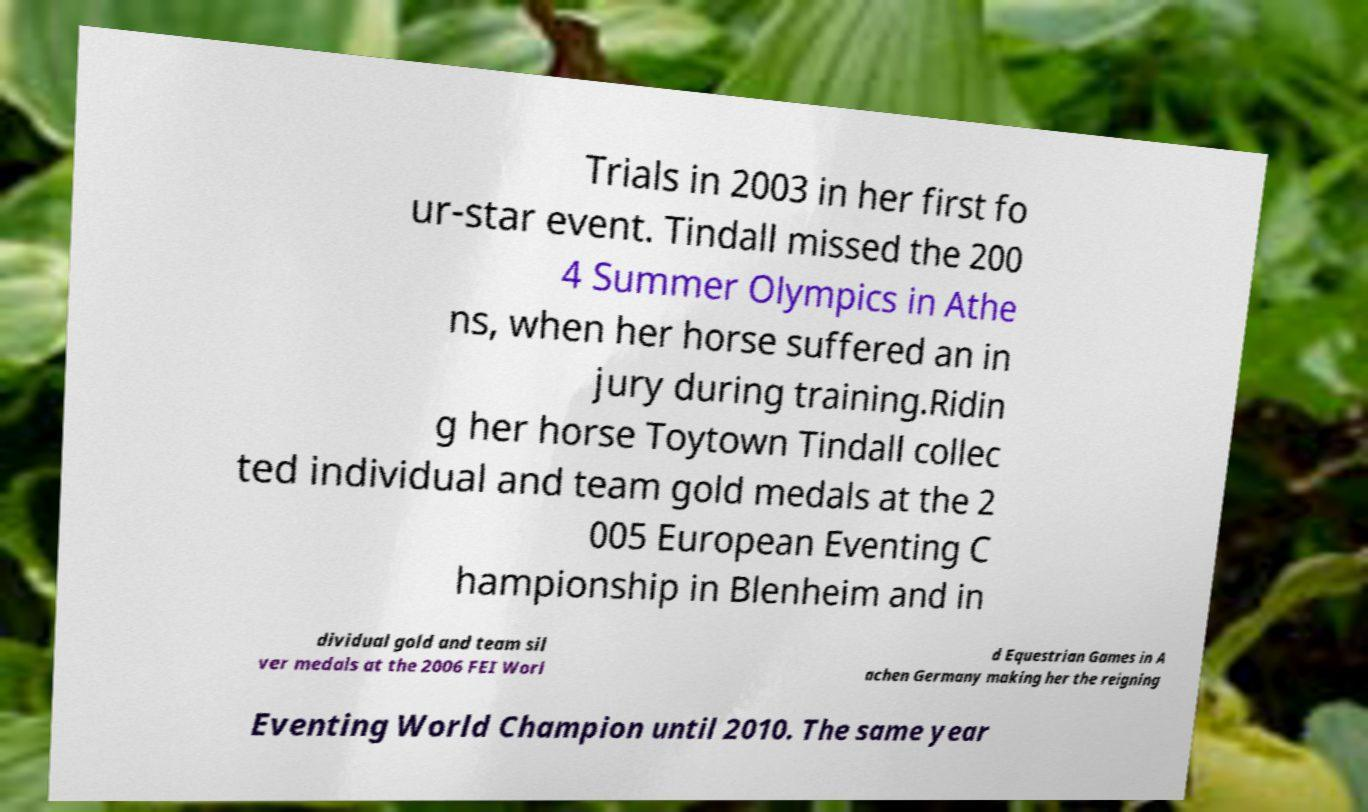Can you accurately transcribe the text from the provided image for me? Trials in 2003 in her first fo ur-star event. Tindall missed the 200 4 Summer Olympics in Athe ns, when her horse suffered an in jury during training.Ridin g her horse Toytown Tindall collec ted individual and team gold medals at the 2 005 European Eventing C hampionship in Blenheim and in dividual gold and team sil ver medals at the 2006 FEI Worl d Equestrian Games in A achen Germany making her the reigning Eventing World Champion until 2010. The same year 